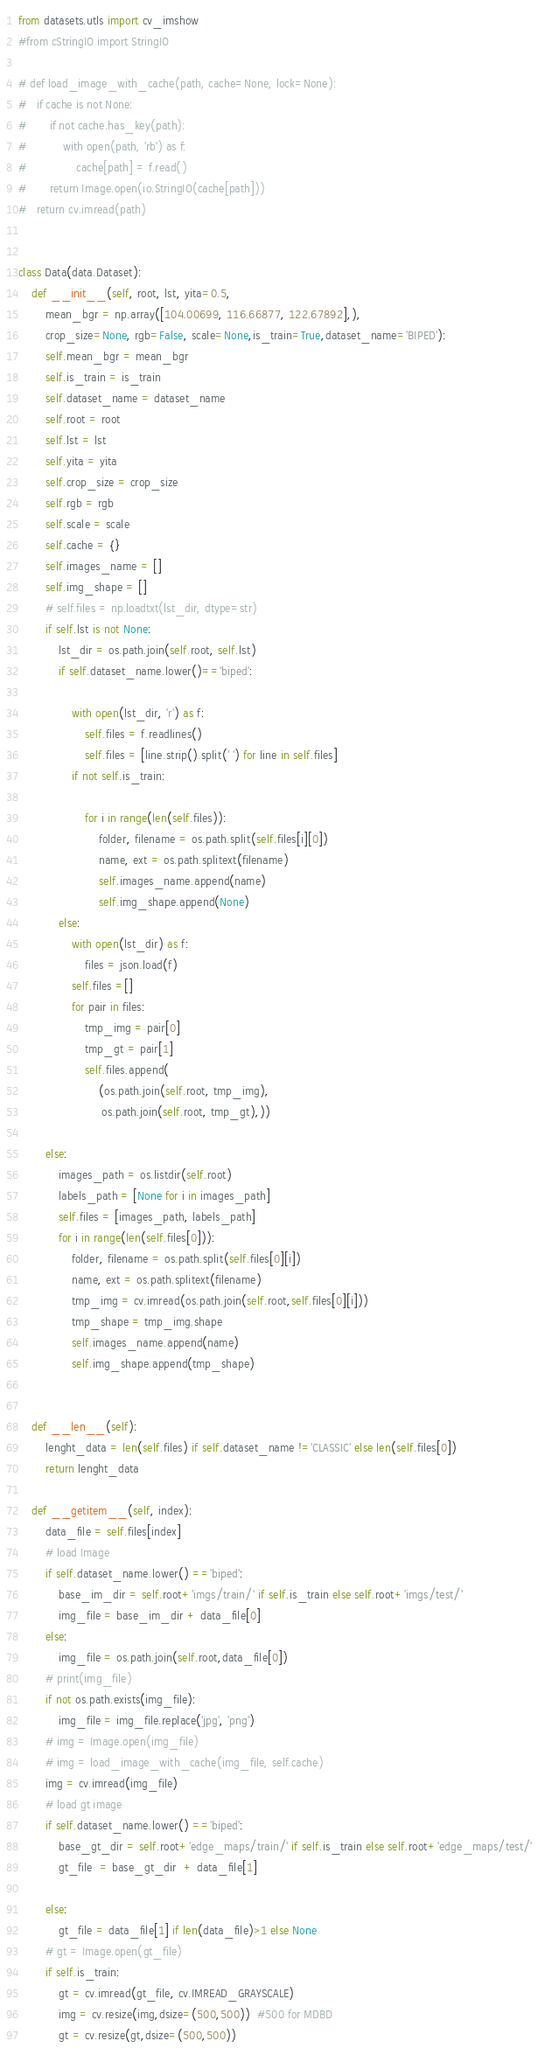Convert code to text. <code><loc_0><loc_0><loc_500><loc_500><_Python_>from datasets.utls import cv_imshow
#from cStringIO import StringIO

# def load_image_with_cache(path, cache=None, lock=None):
# 	if cache is not None:
# 		if not cache.has_key(path):
# 			with open(path, 'rb') as f:
# 				cache[path] = f.read()
# 		return Image.open(io.StringIO(cache[path]))
# 	return cv.imread(path)


class Data(data.Dataset):
	def __init__(self, root, lst, yita=0.5,
		mean_bgr = np.array([104.00699, 116.66877, 122.67892],),
		crop_size=None, rgb=False, scale=None,is_train=True,dataset_name='BIPED'):
		self.mean_bgr = mean_bgr
		self.is_train = is_train
		self.dataset_name = dataset_name
		self.root = root
		self.lst = lst
		self.yita = yita
		self.crop_size = crop_size
		self.rgb = rgb
		self.scale = scale
		self.cache = {}
		self.images_name = []
		self.img_shape = []
		# self.files = np.loadtxt(lst_dir, dtype=str)
		if self.lst is not None:
			lst_dir = os.path.join(self.root, self.lst)
			if self.dataset_name.lower()=='biped':

				with open(lst_dir, 'r') as f:
					self.files = f.readlines()
					self.files = [line.strip().split(' ') for line in self.files]
				if not self.is_train:

					for i in range(len(self.files)):
						folder, filename = os.path.split(self.files[i][0])
						name, ext = os.path.splitext(filename)
						self.images_name.append(name)
						self.img_shape.append(None)
			else:
				with open(lst_dir) as f:
					files = json.load(f)
				self.files =[]
				for pair in files:
					tmp_img = pair[0]
					tmp_gt = pair[1]
					self.files.append(
						(os.path.join(self.root, tmp_img),
						 os.path.join(self.root, tmp_gt),))

		else:
			images_path = os.listdir(self.root)
			labels_path = [None for i in images_path]
			self.files = [images_path, labels_path]
			for i in range(len(self.files[0])):
				folder, filename = os.path.split(self.files[0][i])
				name, ext = os.path.splitext(filename)
				tmp_img = cv.imread(os.path.join(self.root,self.files[0][i]))
				tmp_shape = tmp_img.shape
				self.images_name.append(name)
				self.img_shape.append(tmp_shape)


	def __len__(self):
		lenght_data = len(self.files) if self.dataset_name !='CLASSIC' else len(self.files[0])
		return lenght_data

	def __getitem__(self, index):
		data_file = self.files[index]
		# load Image
		if self.dataset_name.lower() =='biped':
			base_im_dir = self.root+'imgs/train/' if self.is_train else self.root+'imgs/test/'
			img_file = base_im_dir + data_file[0]
		else:
			img_file = os.path.join(self.root,data_file[0])
		# print(img_file)
		if not os.path.exists(img_file):
			img_file = img_file.replace('jpg', 'png')
		# img = Image.open(img_file)
		# img = load_image_with_cache(img_file, self.cache)
		img = cv.imread(img_file)
		# load gt image
		if self.dataset_name.lower() =='biped':
			base_gt_dir = self.root+'edge_maps/train/' if self.is_train else self.root+'edge_maps/test/'
			gt_file  = base_gt_dir  + data_file[1]

		else:
			gt_file = data_file[1] if len(data_file)>1 else None
		# gt = Image.open(gt_file)
		if self.is_train:
			gt = cv.imread(gt_file, cv.IMREAD_GRAYSCALE)
			img = cv.resize(img,dsize=(500,500))  #500 for MDBD
			gt = cv.resize(gt,dsize=(500,500))</code> 